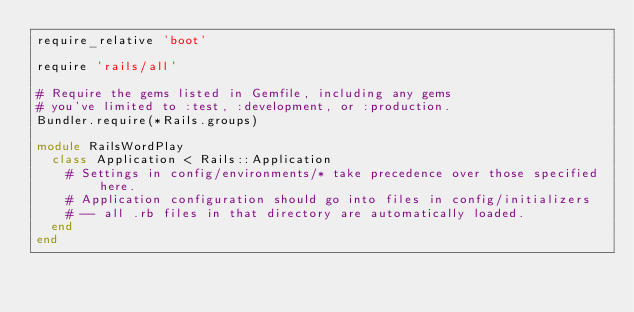Convert code to text. <code><loc_0><loc_0><loc_500><loc_500><_Ruby_>require_relative 'boot'

require 'rails/all'

# Require the gems listed in Gemfile, including any gems
# you've limited to :test, :development, or :production.
Bundler.require(*Rails.groups)

module RailsWordPlay
  class Application < Rails::Application
    # Settings in config/environments/* take precedence over those specified here.
    # Application configuration should go into files in config/initializers
    # -- all .rb files in that directory are automatically loaded.
  end
end
</code> 